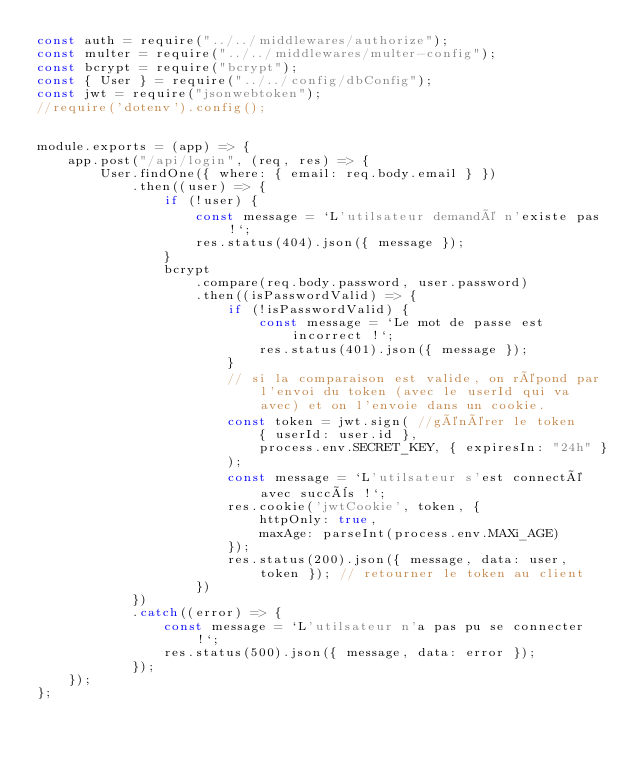<code> <loc_0><loc_0><loc_500><loc_500><_JavaScript_>const auth = require("../../middlewares/authorize");
const multer = require("../../middlewares/multer-config");
const bcrypt = require("bcrypt");
const { User } = require("../../config/dbConfig");
const jwt = require("jsonwebtoken");
//require('dotenv').config();


module.exports = (app) => {
    app.post("/api/login", (req, res) => {
        User.findOne({ where: { email: req.body.email } })
            .then((user) => {
                if (!user) {
                    const message = `L'utilsateur demandé n'existe pas !`;
                    res.status(404).json({ message });
                }
                bcrypt
                    .compare(req.body.password, user.password)
                    .then((isPasswordValid) => {
                        if (!isPasswordValid) {
                            const message = `Le mot de passe est incorrect !`;
                            res.status(401).json({ message });
                        }
                        // si la comparaison est valide, on répond par l'envoi du token (avec le userId qui va avec) et on l'envoie dans un cookie.
                        const token = jwt.sign( //générer le token
                            { userId: user.id },
                            process.env.SECRET_KEY, { expiresIn: "24h" }
                        );
                        const message = `L'utilsateur s'est connecté avec succès !`;
                        res.cookie('jwtCookie', token, {
                            httpOnly: true,
                            maxAge: parseInt(process.env.MAXi_AGE)
                        });
                        res.status(200).json({ message, data: user, token }); // retourner le token au client
                    })
            })
            .catch((error) => {
                const message = `L'utilsateur n'a pas pu se connecter !`;
                res.status(500).json({ message, data: error });
            });
    });
};</code> 